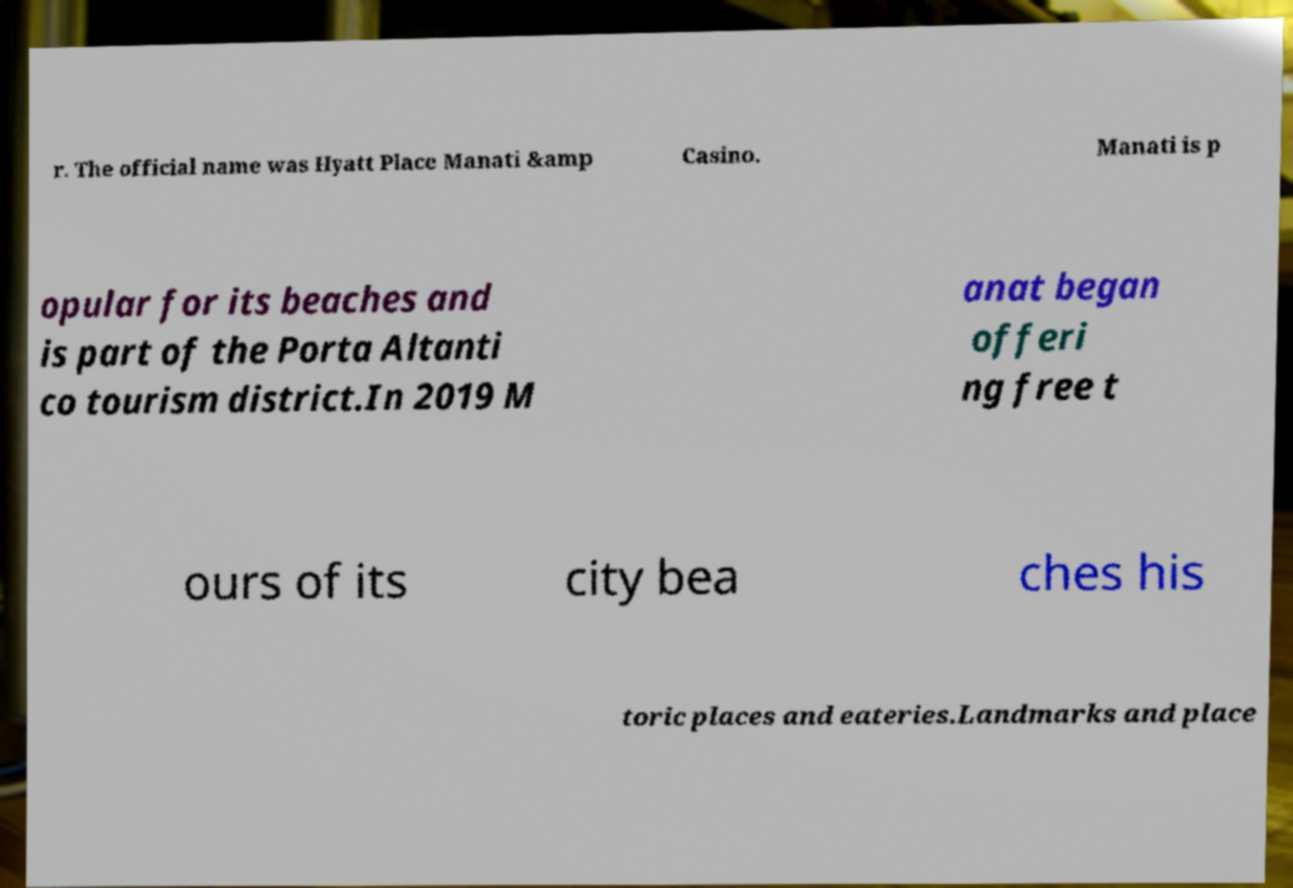Could you assist in decoding the text presented in this image and type it out clearly? r. The official name was Hyatt Place Manati &amp Casino. Manati is p opular for its beaches and is part of the Porta Altanti co tourism district.In 2019 M anat began offeri ng free t ours of its city bea ches his toric places and eateries.Landmarks and place 